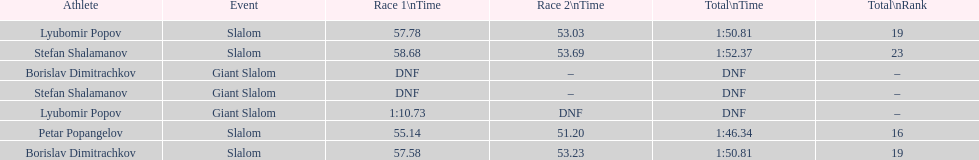What is the number of athletes to finish race one in the giant slalom? 1. 